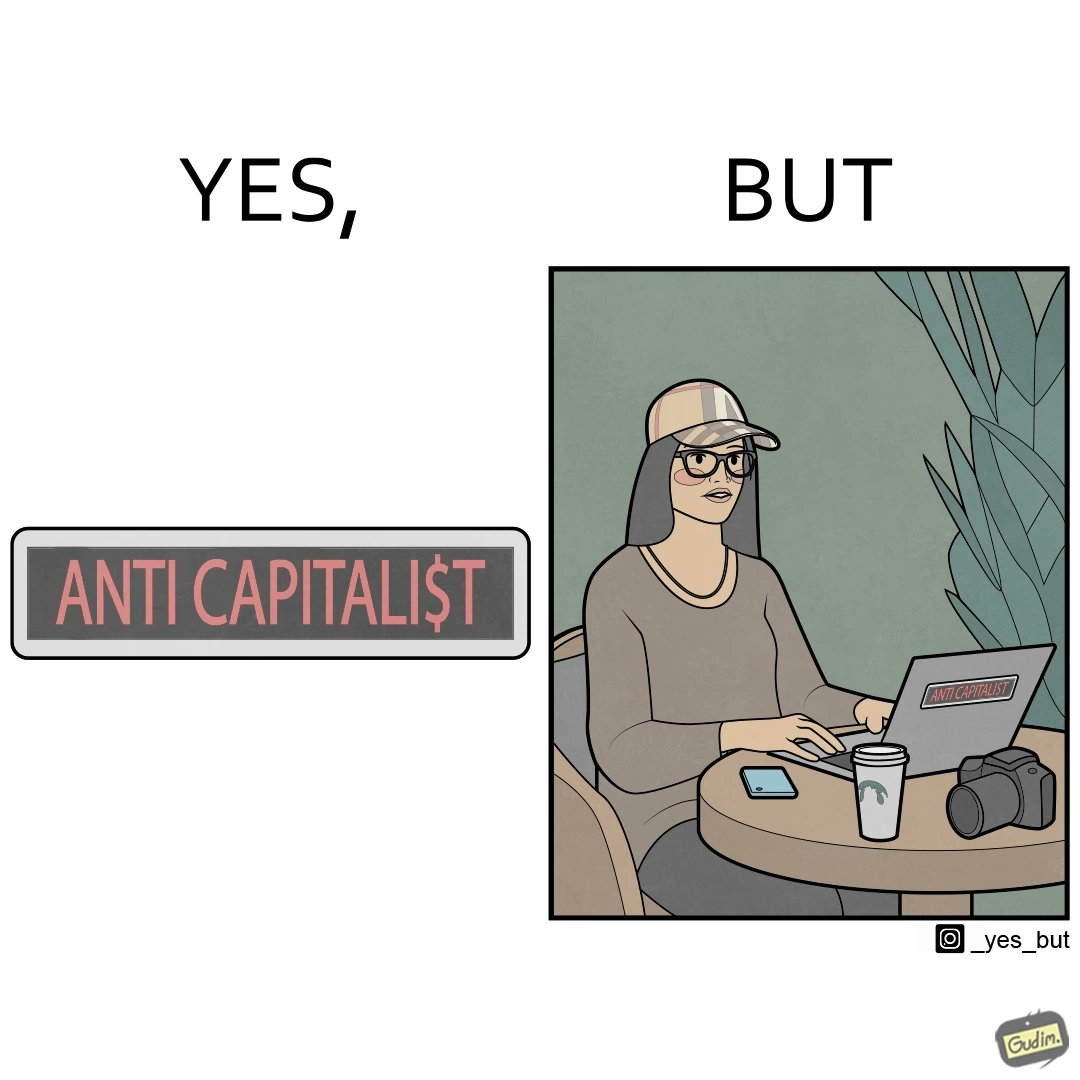Is there satirical content in this image? Yes, this image is satirical. 